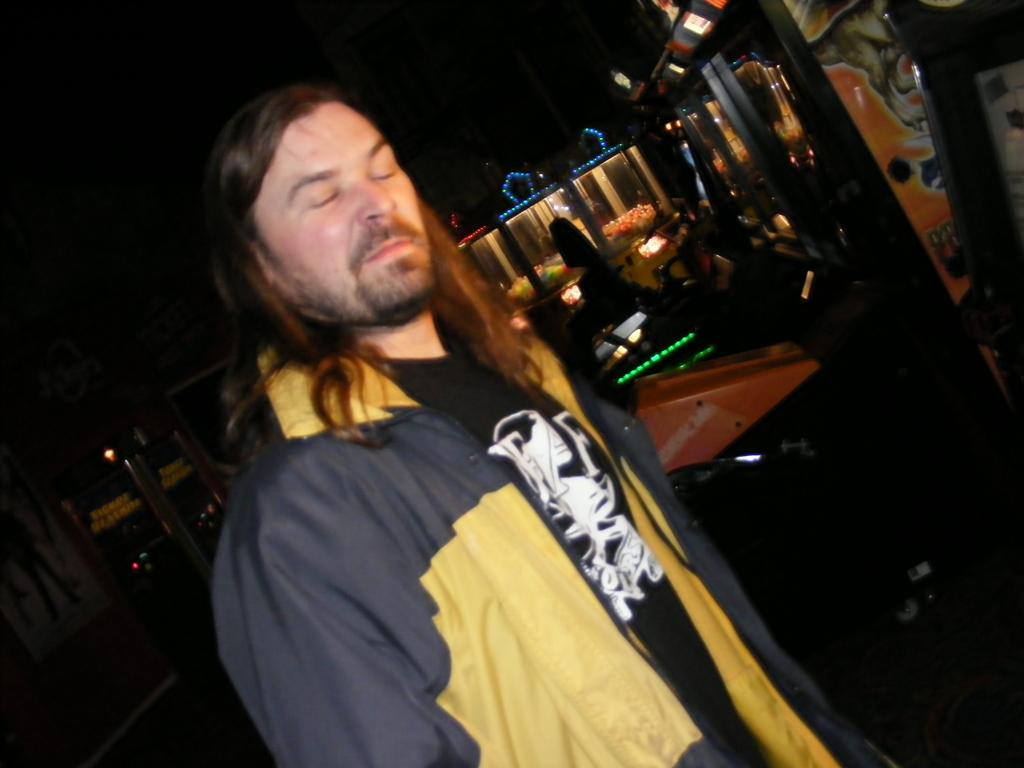What is the main subject of the image? There is a person in the image. What is the person wearing on their upper body? The person is wearing a black t-shirt and a blue and yellow colored jacket. What is the person's posture in the image? The person is standing. What can be seen in the background of the image? The sky is dark, and there are colorful objects in the background. What type of music is being played by the police in the image? There are no police or music present in the image; it features a person wearing a black t-shirt and a blue and yellow colored jacket, standing against a dark sky with colorful objects in the background. 